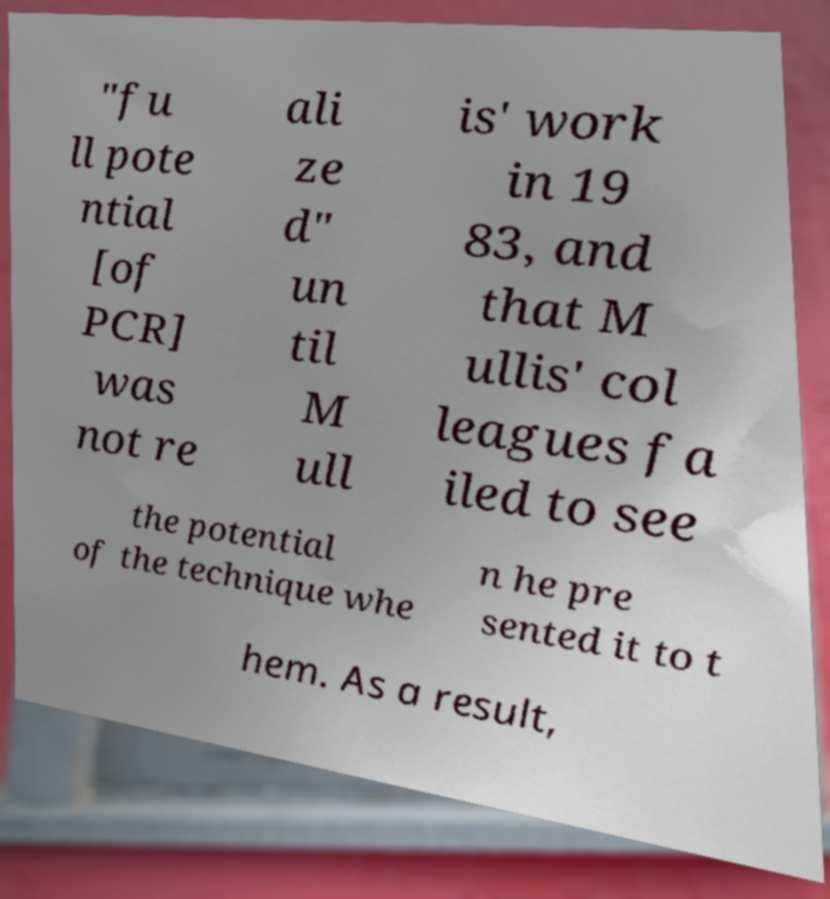Please read and relay the text visible in this image. What does it say? "fu ll pote ntial [of PCR] was not re ali ze d" un til M ull is' work in 19 83, and that M ullis' col leagues fa iled to see the potential of the technique whe n he pre sented it to t hem. As a result, 